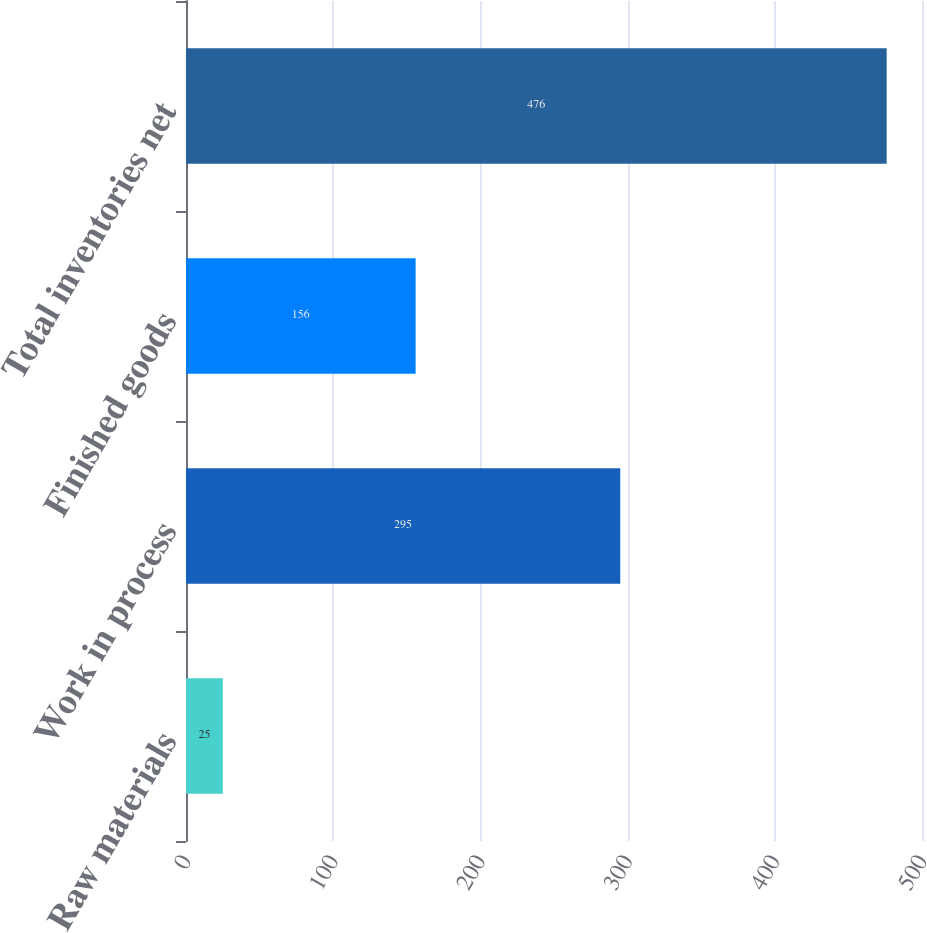Convert chart to OTSL. <chart><loc_0><loc_0><loc_500><loc_500><bar_chart><fcel>Raw materials<fcel>Work in process<fcel>Finished goods<fcel>Total inventories net<nl><fcel>25<fcel>295<fcel>156<fcel>476<nl></chart> 